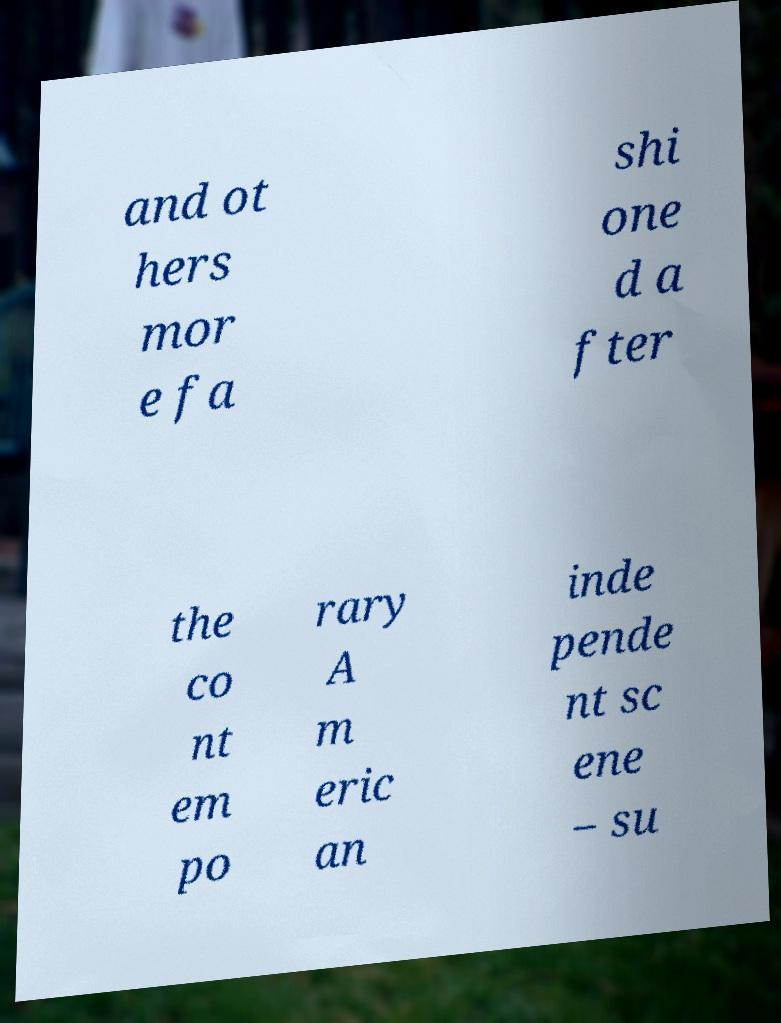I need the written content from this picture converted into text. Can you do that? and ot hers mor e fa shi one d a fter the co nt em po rary A m eric an inde pende nt sc ene – su 